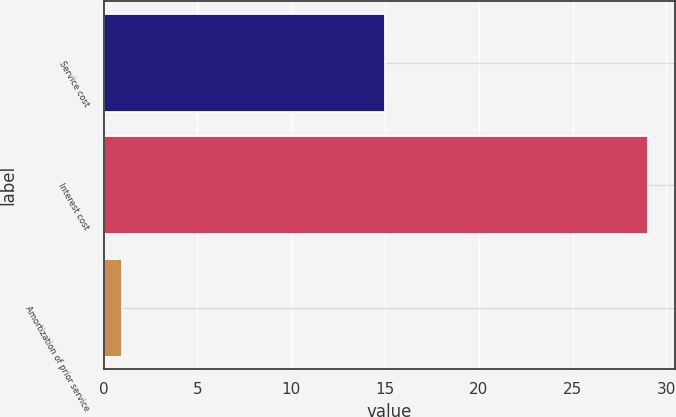Convert chart to OTSL. <chart><loc_0><loc_0><loc_500><loc_500><bar_chart><fcel>Service cost<fcel>Interest cost<fcel>Amortization of prior service<nl><fcel>15<fcel>29<fcel>1<nl></chart> 